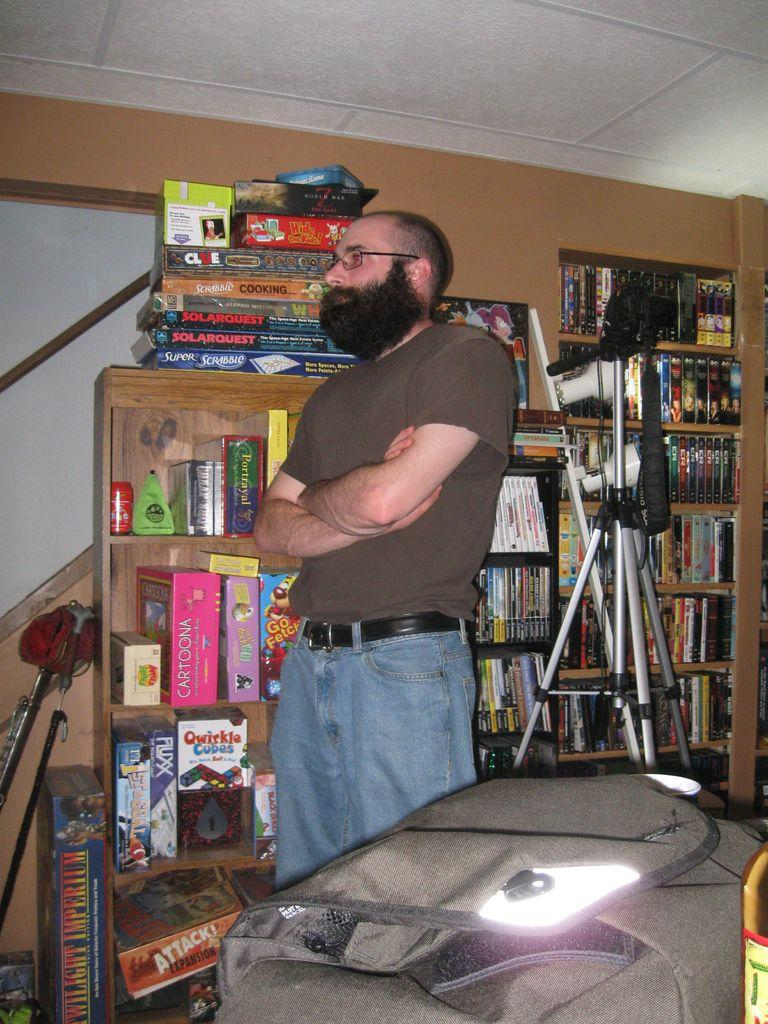<image>
Present a compact description of the photo's key features. a man that is next to a game called Attack 